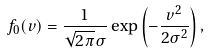Convert formula to latex. <formula><loc_0><loc_0><loc_500><loc_500>f _ { 0 } ( v ) = \frac { 1 } { \sqrt { 2 \pi } \sigma } \exp \left ( - \frac { v ^ { 2 } } { 2 \sigma ^ { 2 } } \right ) ,</formula> 